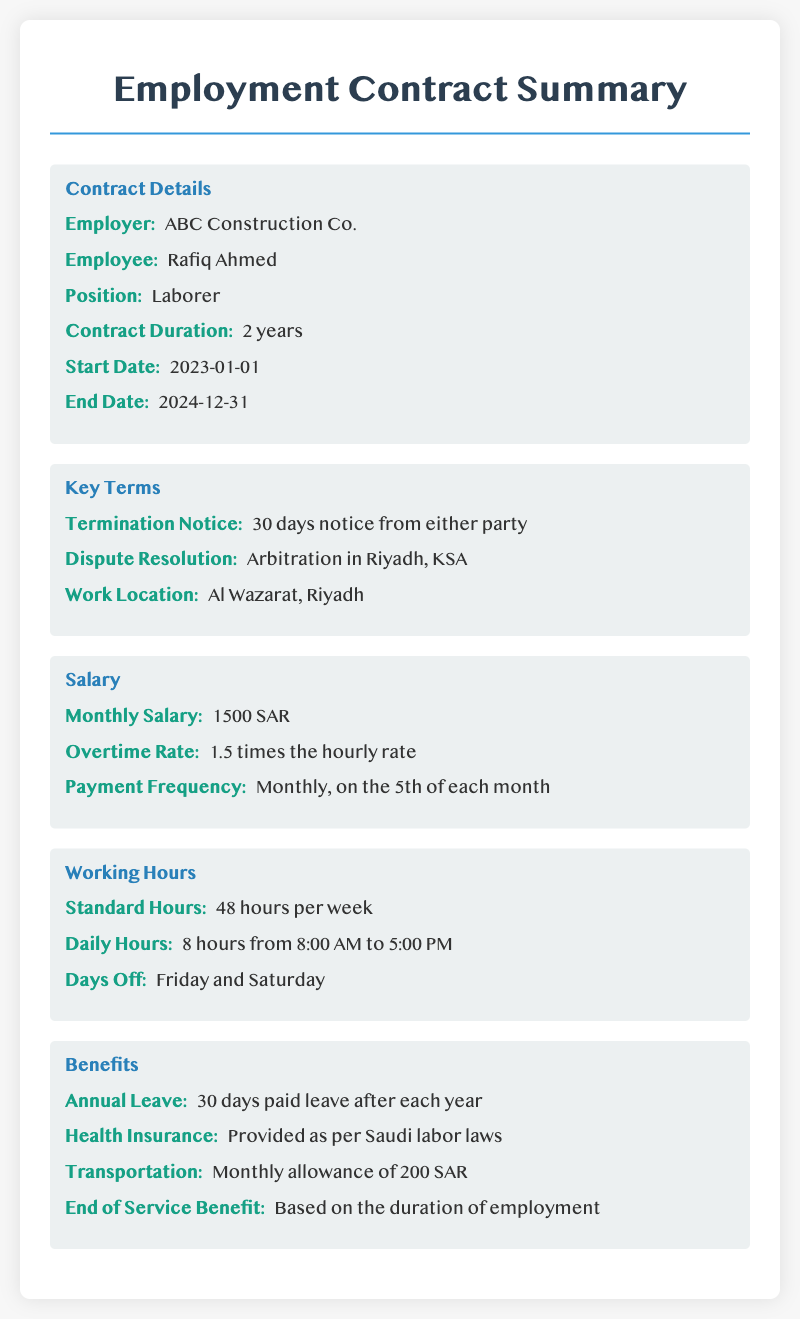What is the employer's name? The employer's name is stated as "ABC Construction Co." in the contract details section.
Answer: ABC Construction Co What is the monthly salary? The monthly salary is mentioned directly under the salary section as "1500 SAR."
Answer: 1500 SAR What are the standard working hours per week? The standard working hours are specified in the working hours section as "48 hours per week."
Answer: 48 hours When does the contract start? The start date of the contract is provided in the contract details section as "2023-01-01."
Answer: 2023-01-01 How many days of annual leave are provided? The annual leave entitlement is clarified in the benefits section, which states "30 days paid leave after each year."
Answer: 30 days What is required for termination notice? The termination notice requirement is detailed in the key terms section as "30 days notice from either party."
Answer: 30 days notice What is the transportation allowance? The transportation benefit is listed in the benefits section as "Monthly allowance of 200 SAR."
Answer: 200 SAR When are the days off? The days off are specified in the working hours section as "Friday and Saturday."
Answer: Friday and Saturday Where will the work location be? The work location is clearly stated in the key terms section as "Al Wazarat, Riyadh."
Answer: Al Wazarat, Riyadh 